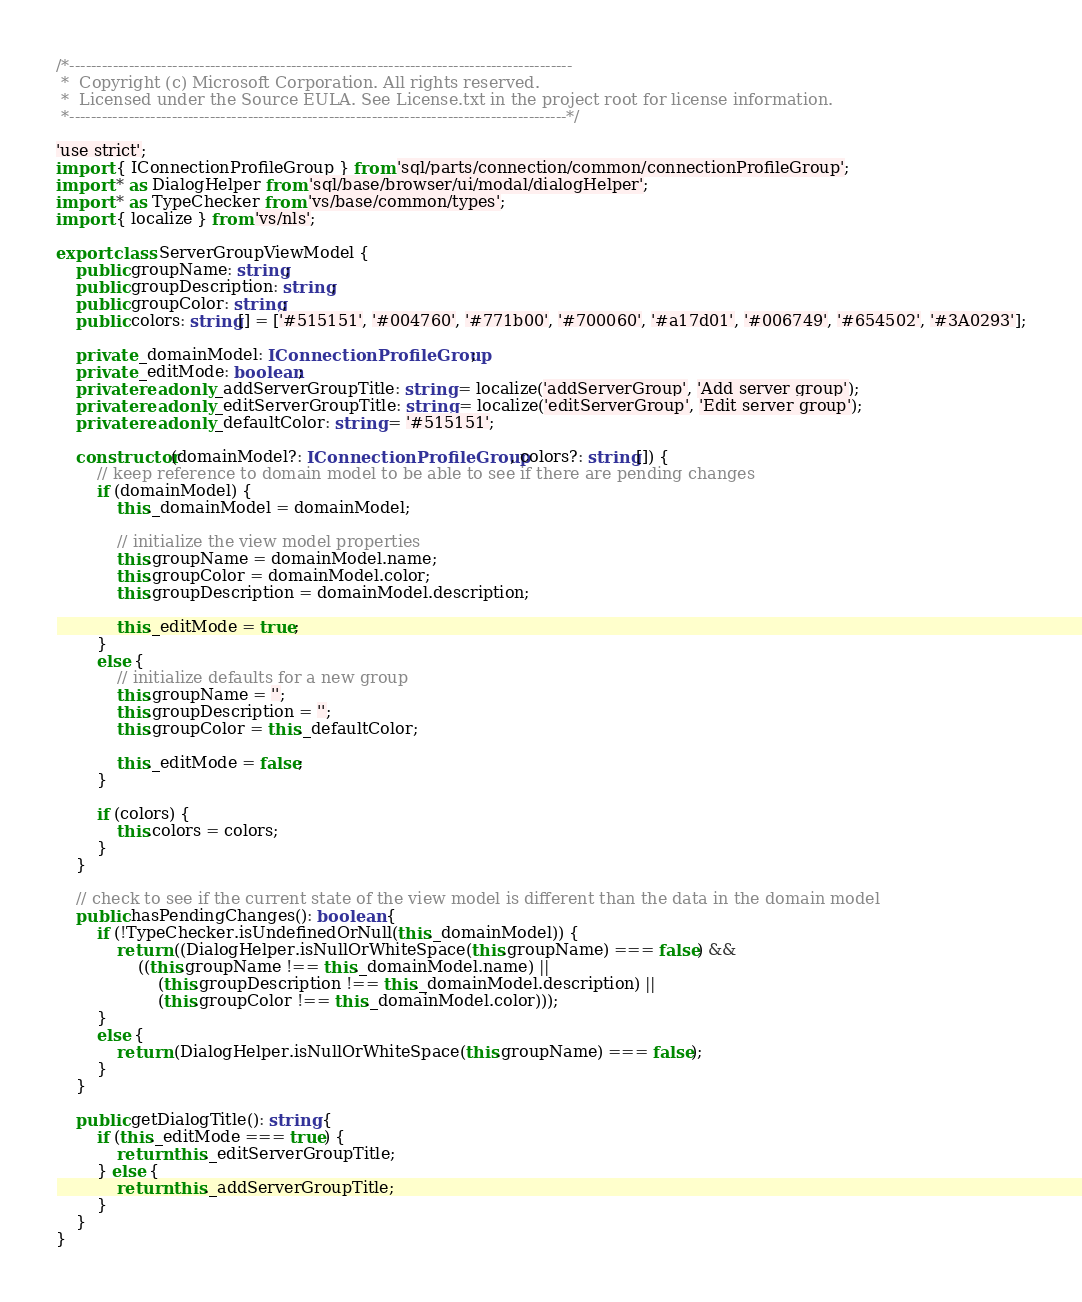Convert code to text. <code><loc_0><loc_0><loc_500><loc_500><_TypeScript_>/*---------------------------------------------------------------------------------------------
 *  Copyright (c) Microsoft Corporation. All rights reserved.
 *  Licensed under the Source EULA. See License.txt in the project root for license information.
 *--------------------------------------------------------------------------------------------*/

'use strict';
import { IConnectionProfileGroup } from 'sql/parts/connection/common/connectionProfileGroup';
import * as DialogHelper from 'sql/base/browser/ui/modal/dialogHelper';
import * as TypeChecker from 'vs/base/common/types';
import { localize } from 'vs/nls';

export class ServerGroupViewModel {
	public groupName: string;
	public groupDescription: string;
	public groupColor: string;
	public colors: string[] = ['#515151', '#004760', '#771b00', '#700060', '#a17d01', '#006749', '#654502', '#3A0293'];

	private _domainModel: IConnectionProfileGroup;
	private _editMode: boolean;
	private readonly _addServerGroupTitle: string = localize('addServerGroup', 'Add server group');
	private readonly _editServerGroupTitle: string = localize('editServerGroup', 'Edit server group');
	private readonly _defaultColor: string = '#515151';

	constructor(domainModel?: IConnectionProfileGroup, colors?: string[]) {
		// keep reference to domain model to be able to see if there are pending changes
		if (domainModel) {
			this._domainModel = domainModel;

			// initialize the view model properties
			this.groupName = domainModel.name;
			this.groupColor = domainModel.color;
			this.groupDescription = domainModel.description;

			this._editMode = true;
		}
		else {
			// initialize defaults for a new group
			this.groupName = '';
			this.groupDescription = '';
			this.groupColor = this._defaultColor;

			this._editMode = false;
		}

		if (colors) {
			this.colors = colors;
		}
	}

	// check to see if the current state of the view model is different than the data in the domain model
	public hasPendingChanges(): boolean {
		if (!TypeChecker.isUndefinedOrNull(this._domainModel)) {
			return ((DialogHelper.isNullOrWhiteSpace(this.groupName) === false) &&
				((this.groupName !== this._domainModel.name) ||
					(this.groupDescription !== this._domainModel.description) ||
					(this.groupColor !== this._domainModel.color)));
		}
		else {
			return (DialogHelper.isNullOrWhiteSpace(this.groupName) === false);
		}
	}

	public getDialogTitle(): string {
		if (this._editMode === true) {
			return this._editServerGroupTitle;
		} else {
			return this._addServerGroupTitle;
		}
	}
}</code> 